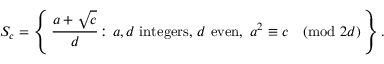Convert formula to latex. <formula><loc_0><loc_0><loc_500><loc_500>S _ { c } = \left \{ \, { \frac { a + { \sqrt { c } } } { d } } \colon a , d { i n t e g e r s , } d { e v e n } , \, a ^ { 2 } \equiv c { \pmod { 2 d } } \, \right \} .</formula> 